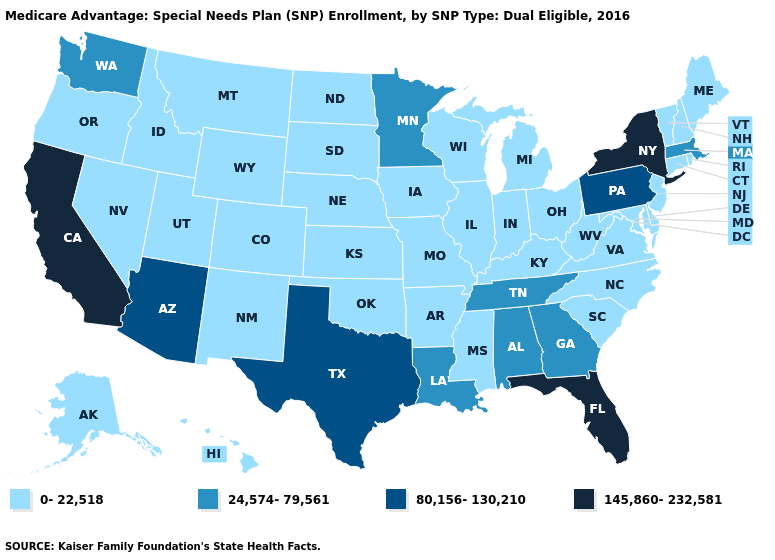What is the value of Montana?
Be succinct. 0-22,518. What is the highest value in states that border Washington?
Concise answer only. 0-22,518. How many symbols are there in the legend?
Answer briefly. 4. What is the value of Missouri?
Keep it brief. 0-22,518. What is the value of Nebraska?
Concise answer only. 0-22,518. Among the states that border South Dakota , which have the highest value?
Quick response, please. Minnesota. What is the value of Arkansas?
Quick response, please. 0-22,518. What is the lowest value in states that border Vermont?
Be succinct. 0-22,518. Name the states that have a value in the range 24,574-79,561?
Concise answer only. Alabama, Georgia, Louisiana, Massachusetts, Minnesota, Tennessee, Washington. What is the value of West Virginia?
Write a very short answer. 0-22,518. What is the lowest value in the Northeast?
Concise answer only. 0-22,518. Does South Carolina have a lower value than Massachusetts?
Keep it brief. Yes. Among the states that border Missouri , which have the highest value?
Short answer required. Tennessee. Which states have the lowest value in the West?
Give a very brief answer. Alaska, Colorado, Hawaii, Idaho, Montana, New Mexico, Nevada, Oregon, Utah, Wyoming. Which states have the lowest value in the South?
Quick response, please. Arkansas, Delaware, Kentucky, Maryland, Mississippi, North Carolina, Oklahoma, South Carolina, Virginia, West Virginia. 